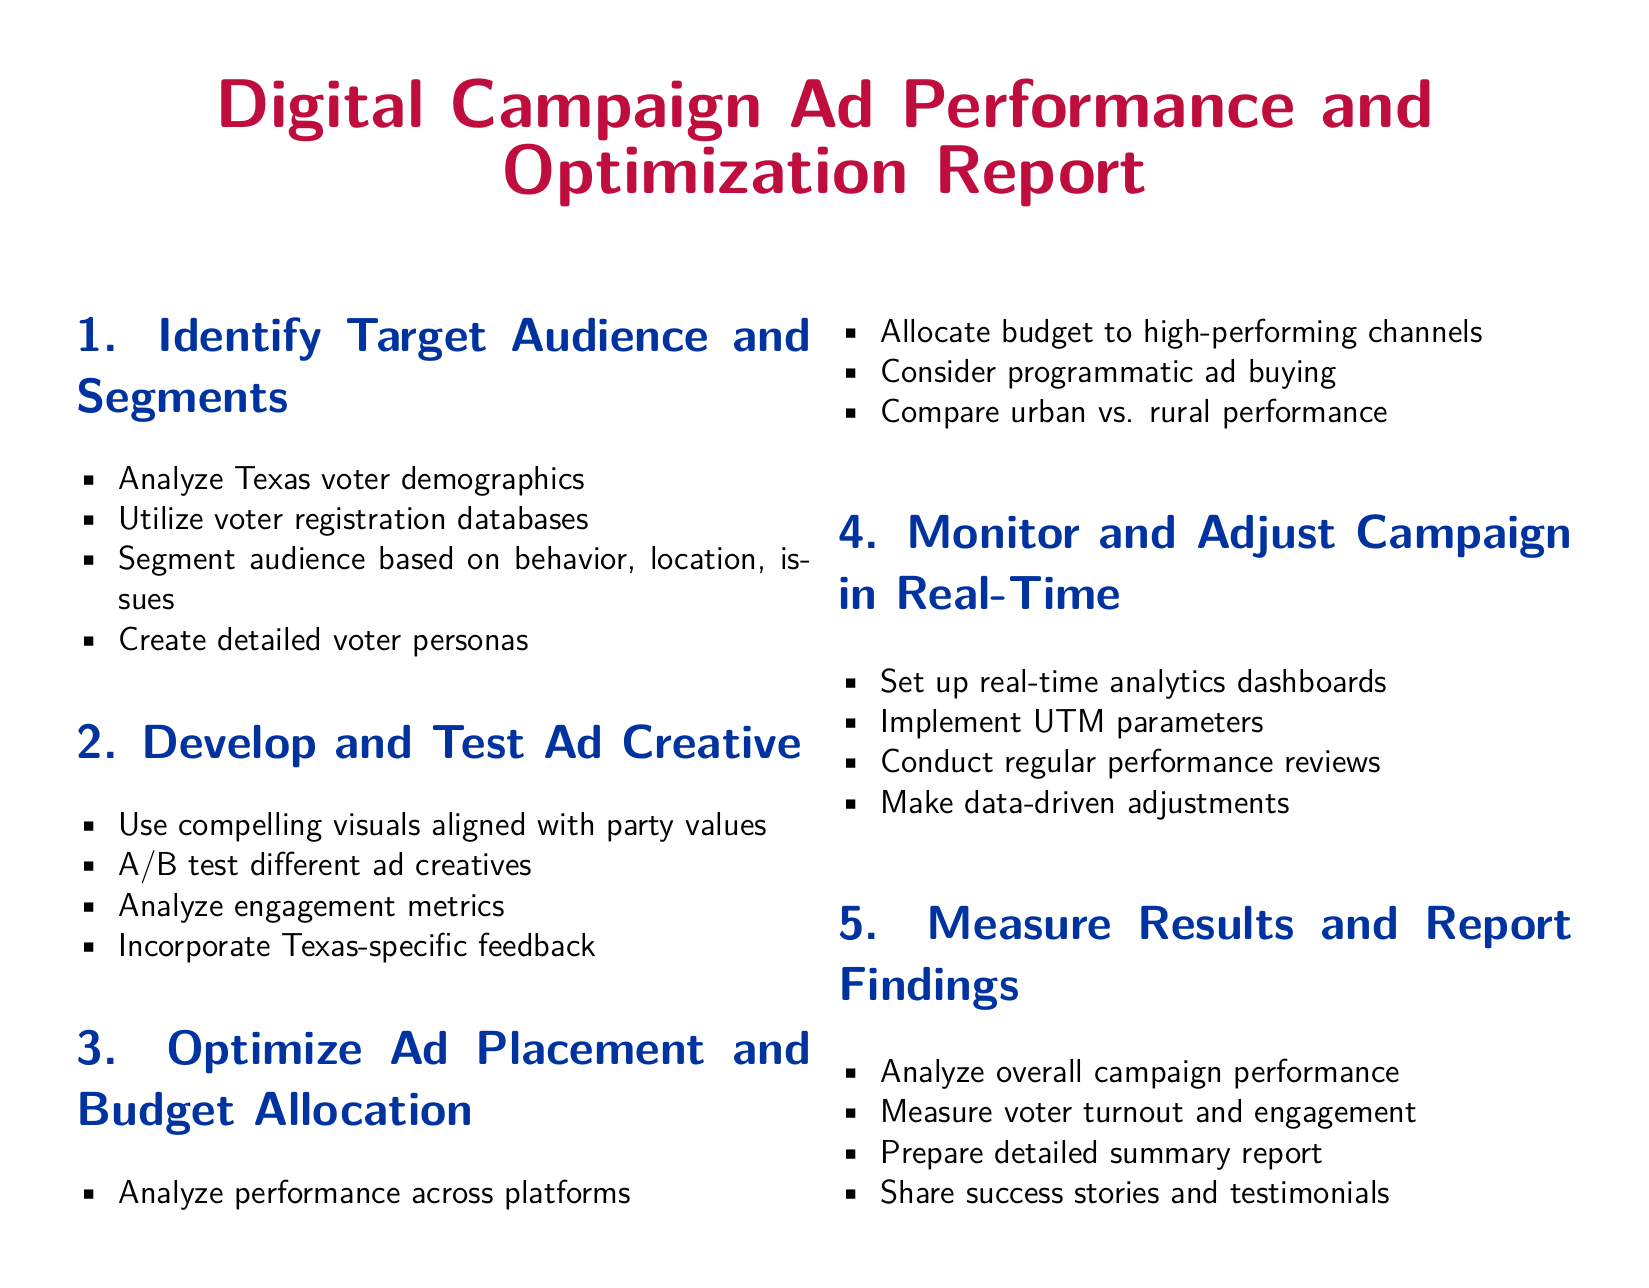What is the primary color used in the document? The primary color used in the document is specified as demblue, which is a specific shade of blue associated with the Democratic Party.
Answer: demblue How many sections are in the report? The report contains five sections that are clearly defined with titles.
Answer: 5 What demographic analysis is suggested for the campaign? The document suggests analyzing Texas voter demographics as part of identifying the target audience.
Answer: Texas voter demographics What is suggested to be tested alongside ad creatives? A/B testing is recommended to evaluate the effectiveness of different ad creatives.
Answer: A/B test What should be included in the budget allocation strategy? The document mentions the importance of allocating the budget to high-performing channels based on performance analysis.
Answer: High-performing channels What method is recommended for monitoring campaign performance? The report suggests setting up real-time analytics dashboards to monitor the campaign effectively.
Answer: Real-time analytics dashboards Which type of targeting is advised for audience segmentation? The report mentions segmenting the audience based on behavior, location, and issues related to the campaign.
Answer: Behavior, location, issues What type of metrics should be analyzed to evaluate ad creative performance? Engagement metrics are emphasized in the report for analyzing ad creative performance during testing.
Answer: Engagement metrics What is the purpose of UTM parameters in the campaign? UTM parameters are implemented to track campaign performance effectively and gather precise data.
Answer: Track campaign performance 